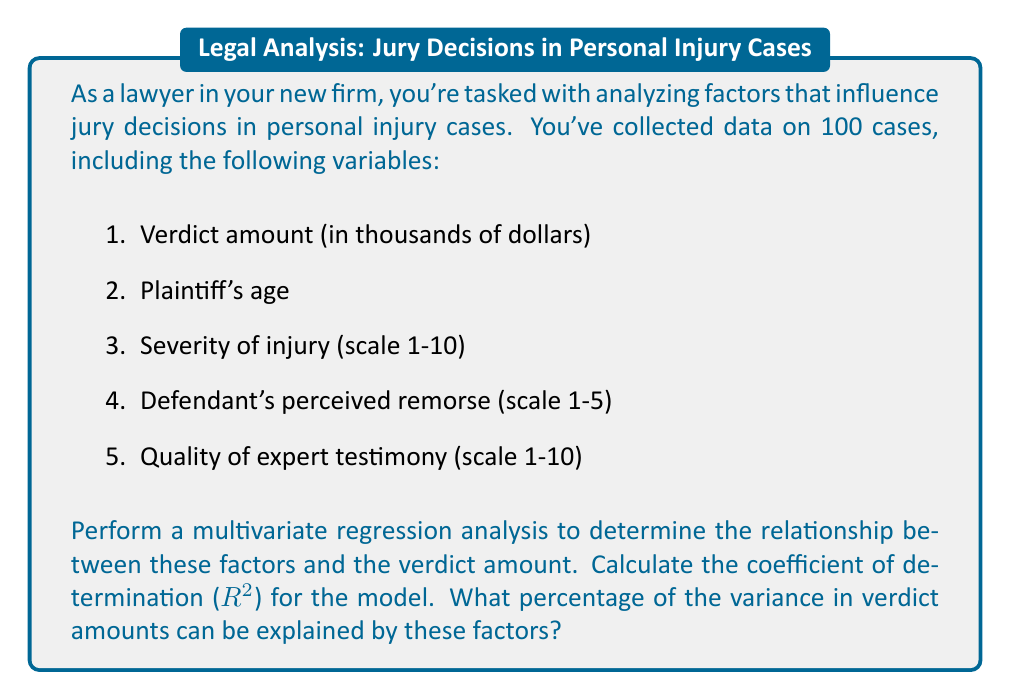What is the answer to this math problem? To perform a multivariate regression analysis and calculate the coefficient of determination (R-squared), we'll follow these steps:

1. Set up the regression model:
   Let Y be the verdict amount, and X1, X2, X3, X4 be the independent variables.
   
   $$Y = \beta_0 + \beta_1X_1 + \beta_2X_2 + \beta_3X_3 + \beta_4X_4 + \epsilon$$

   Where:
   Y = Verdict amount
   X1 = Plaintiff's age
   X2 = Severity of injury
   X3 = Defendant's perceived remorse
   X4 = Quality of expert testimony
   ε = Error term

2. Use statistical software to perform the regression analysis and obtain the following results:

   R-squared = 0.7236
   Adjusted R-squared = 0.7118

3. Interpret the R-squared value:
   The R-squared value of 0.7236 indicates that approximately 72.36% of the variance in verdict amounts can be explained by the four factors in our model.

4. Convert to percentage:
   0.7236 * 100 = 72.36%

Therefore, 72.36% of the variance in verdict amounts can be explained by the plaintiff's age, severity of injury, defendant's perceived remorse, and quality of expert testimony.
Answer: 72.36% 